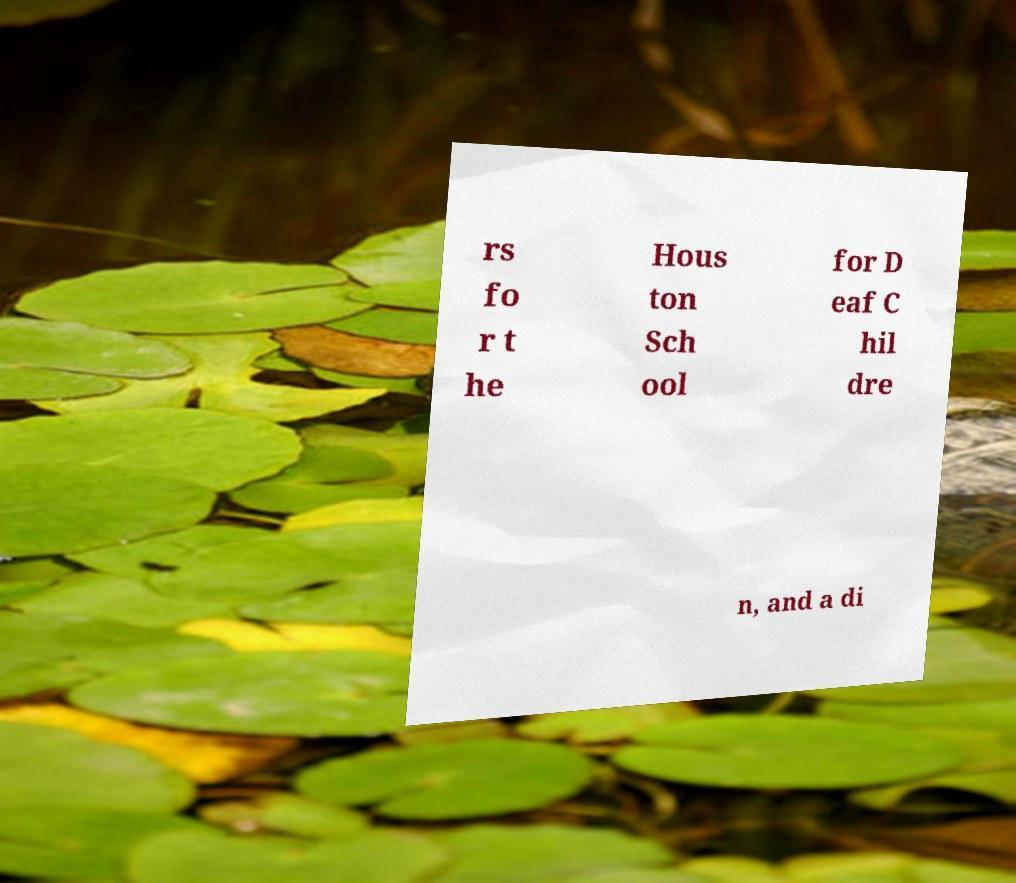I need the written content from this picture converted into text. Can you do that? rs fo r t he Hous ton Sch ool for D eaf C hil dre n, and a di 